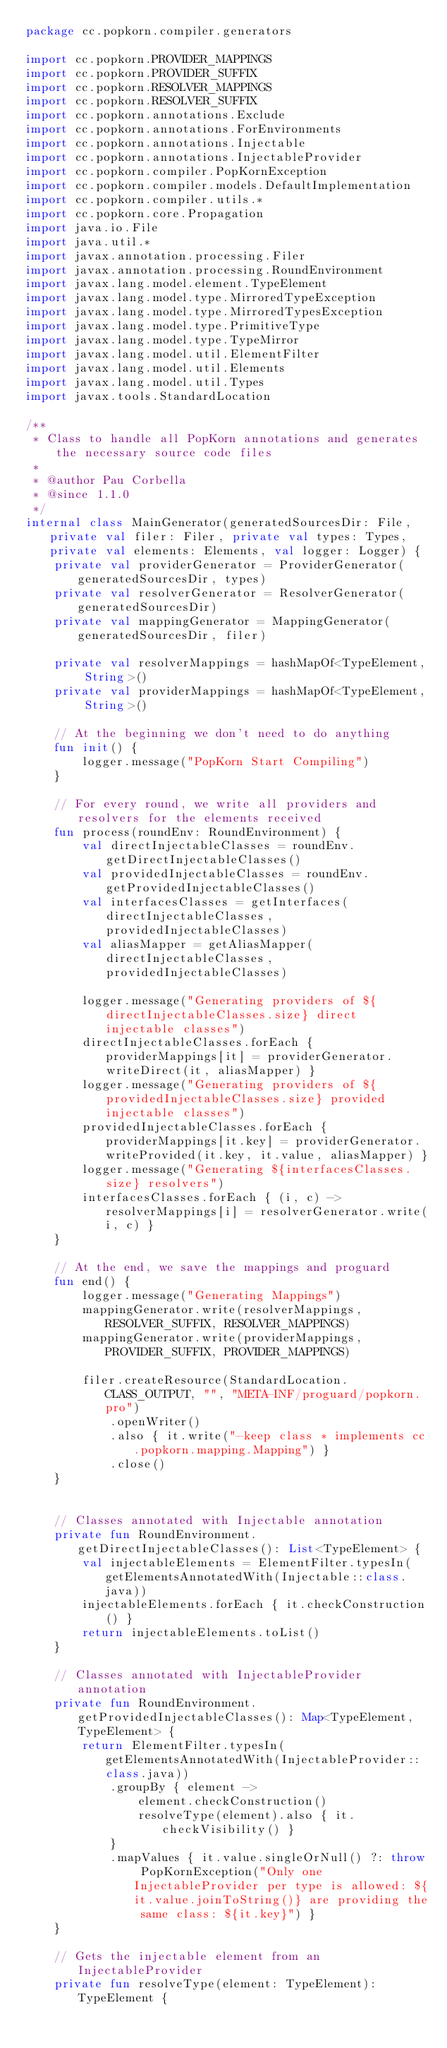Convert code to text. <code><loc_0><loc_0><loc_500><loc_500><_Kotlin_>package cc.popkorn.compiler.generators

import cc.popkorn.PROVIDER_MAPPINGS
import cc.popkorn.PROVIDER_SUFFIX
import cc.popkorn.RESOLVER_MAPPINGS
import cc.popkorn.RESOLVER_SUFFIX
import cc.popkorn.annotations.Exclude
import cc.popkorn.annotations.ForEnvironments
import cc.popkorn.annotations.Injectable
import cc.popkorn.annotations.InjectableProvider
import cc.popkorn.compiler.PopKornException
import cc.popkorn.compiler.models.DefaultImplementation
import cc.popkorn.compiler.utils.*
import cc.popkorn.core.Propagation
import java.io.File
import java.util.*
import javax.annotation.processing.Filer
import javax.annotation.processing.RoundEnvironment
import javax.lang.model.element.TypeElement
import javax.lang.model.type.MirroredTypeException
import javax.lang.model.type.MirroredTypesException
import javax.lang.model.type.PrimitiveType
import javax.lang.model.type.TypeMirror
import javax.lang.model.util.ElementFilter
import javax.lang.model.util.Elements
import javax.lang.model.util.Types
import javax.tools.StandardLocation

/**
 * Class to handle all PopKorn annotations and generates the necessary source code files
 *
 * @author Pau Corbella
 * @since 1.1.0
 */
internal class MainGenerator(generatedSourcesDir: File, private val filer: Filer, private val types: Types, private val elements: Elements, val logger: Logger) {
    private val providerGenerator = ProviderGenerator(generatedSourcesDir, types)
    private val resolverGenerator = ResolverGenerator(generatedSourcesDir)
    private val mappingGenerator = MappingGenerator(generatedSourcesDir, filer)

    private val resolverMappings = hashMapOf<TypeElement, String>()
    private val providerMappings = hashMapOf<TypeElement, String>()

    // At the beginning we don't need to do anything
    fun init() {
        logger.message("PopKorn Start Compiling")
    }

    // For every round, we write all providers and resolvers for the elements received
    fun process(roundEnv: RoundEnvironment) {
        val directInjectableClasses = roundEnv.getDirectInjectableClasses()
        val providedInjectableClasses = roundEnv.getProvidedInjectableClasses()
        val interfacesClasses = getInterfaces(directInjectableClasses, providedInjectableClasses)
        val aliasMapper = getAliasMapper(directInjectableClasses, providedInjectableClasses)

        logger.message("Generating providers of ${directInjectableClasses.size} direct injectable classes")
        directInjectableClasses.forEach { providerMappings[it] = providerGenerator.writeDirect(it, aliasMapper) }
        logger.message("Generating providers of ${providedInjectableClasses.size} provided injectable classes")
        providedInjectableClasses.forEach { providerMappings[it.key] = providerGenerator.writeProvided(it.key, it.value, aliasMapper) }
        logger.message("Generating ${interfacesClasses.size} resolvers")
        interfacesClasses.forEach { (i, c) -> resolverMappings[i] = resolverGenerator.write(i, c) }
    }

    // At the end, we save the mappings and proguard
    fun end() {
        logger.message("Generating Mappings")
        mappingGenerator.write(resolverMappings, RESOLVER_SUFFIX, RESOLVER_MAPPINGS)
        mappingGenerator.write(providerMappings, PROVIDER_SUFFIX, PROVIDER_MAPPINGS)

        filer.createResource(StandardLocation.CLASS_OUTPUT, "", "META-INF/proguard/popkorn.pro")
            .openWriter()
            .also { it.write("-keep class * implements cc.popkorn.mapping.Mapping") }
            .close()
    }


    // Classes annotated with Injectable annotation
    private fun RoundEnvironment.getDirectInjectableClasses(): List<TypeElement> {
        val injectableElements = ElementFilter.typesIn(getElementsAnnotatedWith(Injectable::class.java))
        injectableElements.forEach { it.checkConstruction() }
        return injectableElements.toList()
    }

    // Classes annotated with InjectableProvider annotation
    private fun RoundEnvironment.getProvidedInjectableClasses(): Map<TypeElement, TypeElement> {
        return ElementFilter.typesIn(getElementsAnnotatedWith(InjectableProvider::class.java))
            .groupBy { element ->
                element.checkConstruction()
                resolveType(element).also { it.checkVisibility() }
            }
            .mapValues { it.value.singleOrNull() ?: throw PopKornException("Only one InjectableProvider per type is allowed: ${it.value.joinToString()} are providing the same class: ${it.key}") }
    }

    // Gets the injectable element from an InjectableProvider
    private fun resolveType(element: TypeElement): TypeElement {</code> 